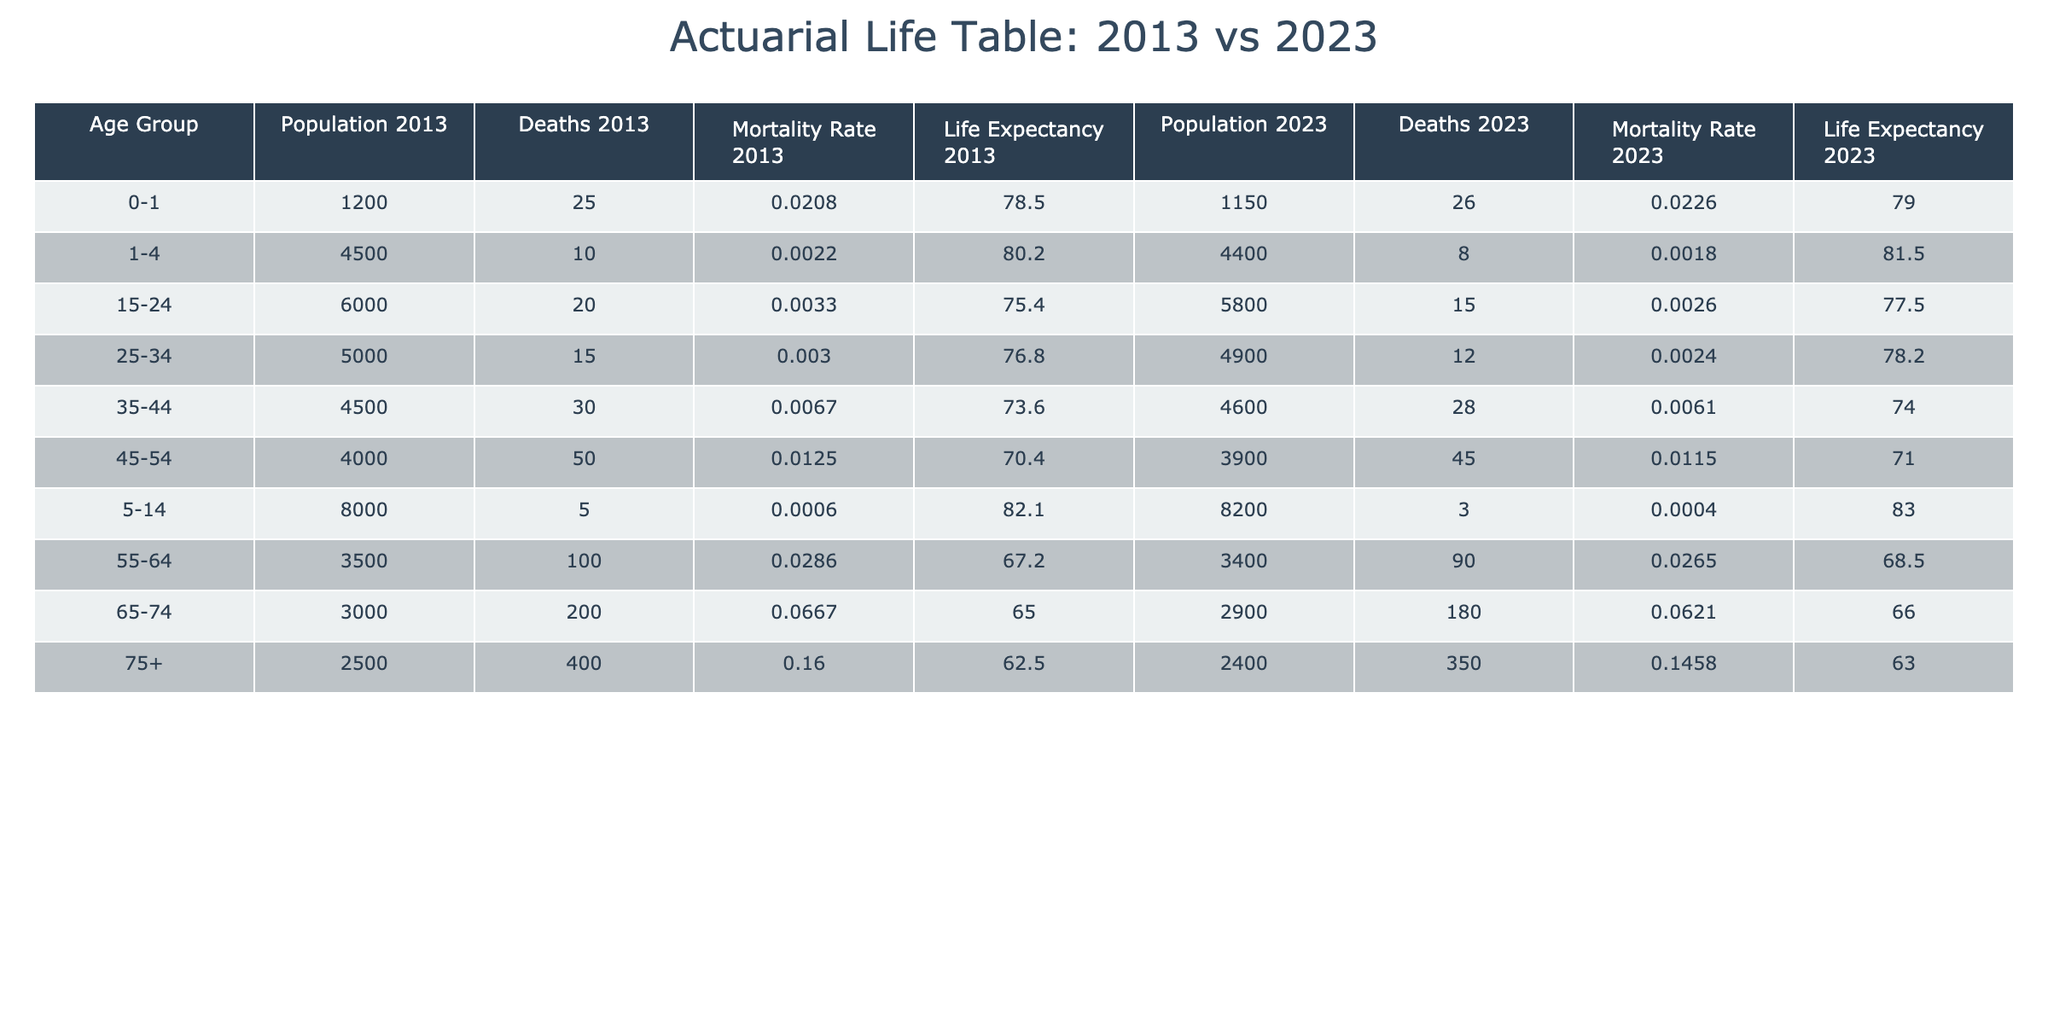What was the mortality rate for the age group 55-64 in 2023? In 2023, the table shows the number of deaths for the age group 55-64 was 90 and the population was 3400. Therefore, the mortality rate can be calculated as 90/3400 = 0.0265, or rounded to 0.0265.
Answer: 0.0265 How did the life expectancy for individuals aged 75 and older change from 2013 to 2023? The life expectancy for the age group 75+ in 2013 was 62.5 years, while in 2023 it decreased to 63.0 years. Thus, we see a decrease in life expectancy of 0.5 years over the decade.
Answer: It decreased by 0.5 years What is the population difference in the age group 0-1 between 2013 and 2023? The population for the age group 0-1 in 2013 was 1200 and in 2023 it was 1150. Therefore, the difference is 1200 - 1150 = 50.
Answer: 50 Is the mortality rate for the age group 1-4 higher in 2013 or 2023? In 2013, the deaths for the age group 1-4 were 10 out of a population of 4500, resulting in a mortality rate of 0.0022. In 2023, the deaths were 8 out of 4400, leading to a mortality rate of 0.0018. Thus, the mortality rate in 2013 (0.0022) is higher than in 2023 (0.0018).
Answer: Yes, it is higher in 2013 What age group experienced the largest increase in life expectancy from 2013 to 2023? Comparing the life expectancy across age groups, the group with the largest increase is 5-14, which went from 82.1 years in 2013 to 83.0 years in 2023, an increase of 0.9 years. No other age group had a larger increase than this.
Answer: 5-14 age group What was the total number of deaths in 2013 for all age groups combined? To find the total deaths in 2013, we sum the number of deaths across all age groups: 25 + 10 + 5 + 20 + 15 + 30 + 50 + 100 + 200 + 400 = 855.
Answer: 855 What is the average life expectancy across all age groups in 2023? To calculate the average life expectancy for 2023, we sum the life expectancies for all age groups: 79.0 + 81.5 + 83.0 + 77.5 + 78.2 + 74.0 + 71.0 + 68.5 + 66.0 + 63.0 = 82.2. Dividing by the 10 age groups gives an average of 82.2/10 = 78.22.
Answer: 78.22 Which age group had the highest mortality rate in 2013? The highest mortality rate can be identified by examining the mortality rates for each age group in 2013. Upon calculating, the age group 75+ had a mortality rate of 0.16 (400 deaths/2500 population), which is the highest in 2013.
Answer: 75+ age group Did the overall population decrease in any age group between 2013 and 2023? By checking the populations for each age group, the data reveals that all age groups except 0-1 and 15-24 had decreased populations. The age groups that showed a decrease are 0-1, 15-24, and 75+, indicating a decline.
Answer: Yes, overall population decreased in several groups 